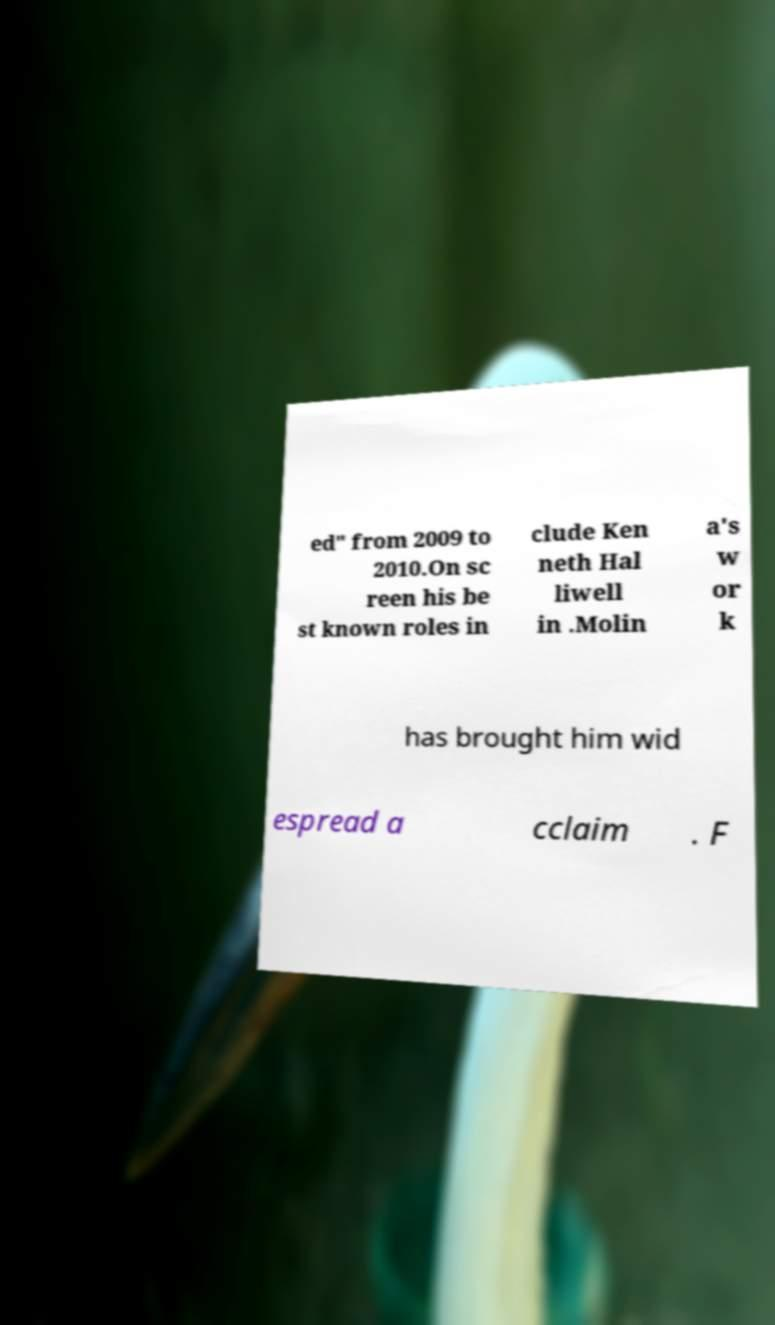Please read and relay the text visible in this image. What does it say? ed" from 2009 to 2010.On sc reen his be st known roles in clude Ken neth Hal liwell in .Molin a's w or k has brought him wid espread a cclaim . F 